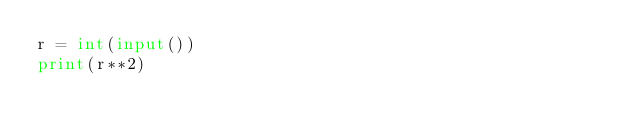<code> <loc_0><loc_0><loc_500><loc_500><_Python_>r = int(input())
print(r**2)</code> 